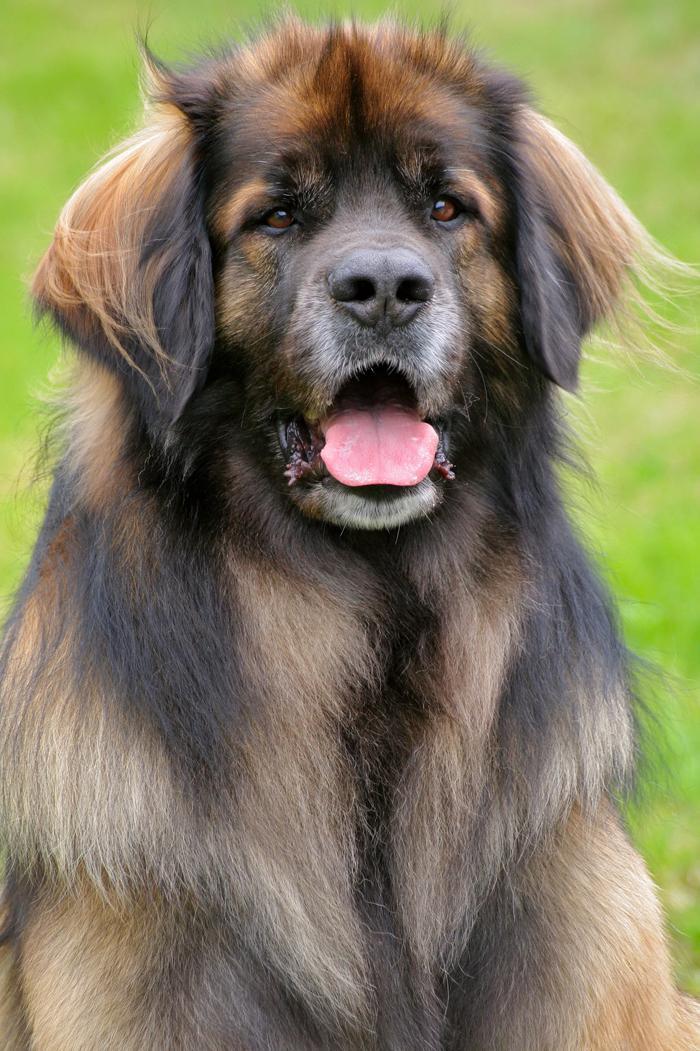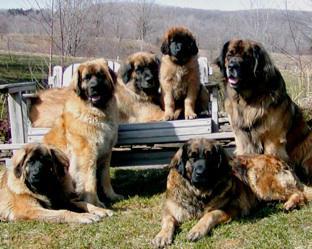The first image is the image on the left, the second image is the image on the right. Assess this claim about the two images: "In one image there are multiple dogs sitting outside.". Correct or not? Answer yes or no. Yes. The first image is the image on the left, the second image is the image on the right. Considering the images on both sides, is "There are at most three dogs." valid? Answer yes or no. No. 